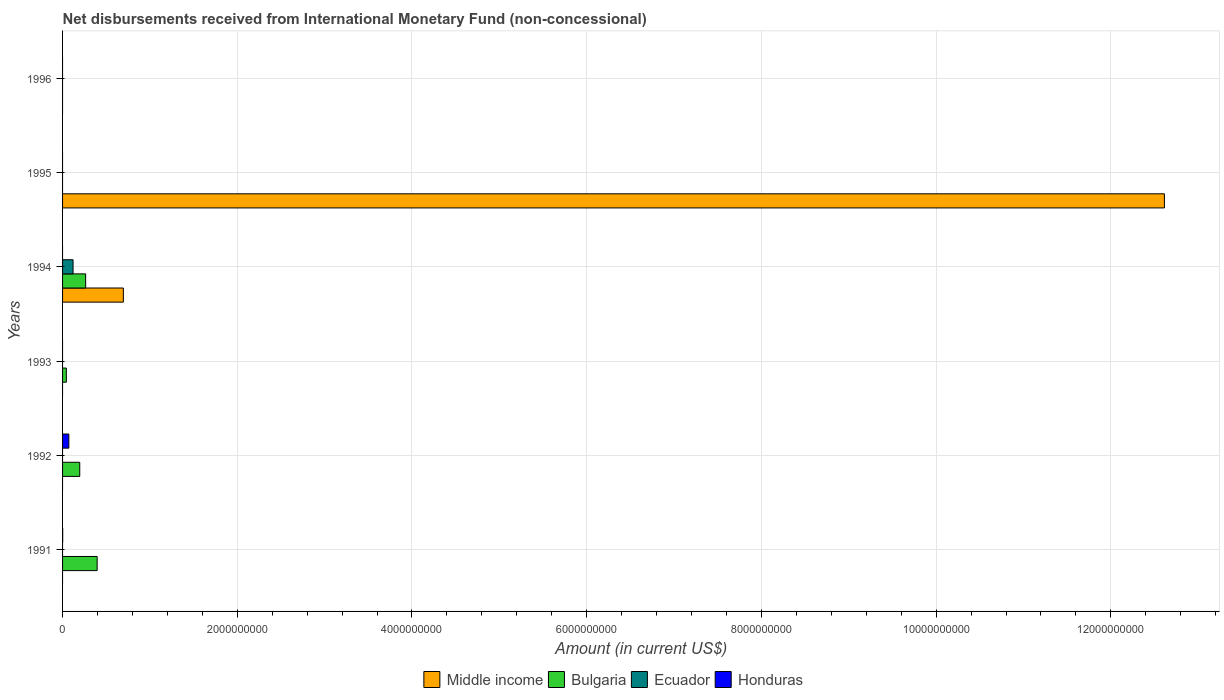How many different coloured bars are there?
Offer a very short reply. 4. Are the number of bars per tick equal to the number of legend labels?
Provide a short and direct response. No. How many bars are there on the 5th tick from the top?
Provide a succinct answer. 2. How many bars are there on the 4th tick from the bottom?
Make the answer very short. 3. What is the amount of disbursements received from International Monetary Fund in Ecuador in 1993?
Your answer should be very brief. 0. Across all years, what is the maximum amount of disbursements received from International Monetary Fund in Middle income?
Offer a very short reply. 1.26e+1. In which year was the amount of disbursements received from International Monetary Fund in Ecuador maximum?
Ensure brevity in your answer.  1994. What is the total amount of disbursements received from International Monetary Fund in Middle income in the graph?
Your answer should be compact. 1.33e+1. What is the difference between the amount of disbursements received from International Monetary Fund in Bulgaria in 1993 and that in 1994?
Offer a terse response. -2.21e+08. What is the difference between the amount of disbursements received from International Monetary Fund in Honduras in 1992 and the amount of disbursements received from International Monetary Fund in Middle income in 1996?
Your response must be concise. 7.19e+07. What is the average amount of disbursements received from International Monetary Fund in Middle income per year?
Make the answer very short. 2.22e+09. In the year 1991, what is the difference between the amount of disbursements received from International Monetary Fund in Honduras and amount of disbursements received from International Monetary Fund in Bulgaria?
Provide a succinct answer. -3.94e+08. What is the ratio of the amount of disbursements received from International Monetary Fund in Bulgaria in 1991 to that in 1993?
Your answer should be very brief. 9.14. What is the difference between the highest and the second highest amount of disbursements received from International Monetary Fund in Bulgaria?
Make the answer very short. 1.32e+08. What is the difference between the highest and the lowest amount of disbursements received from International Monetary Fund in Honduras?
Ensure brevity in your answer.  7.19e+07. Is it the case that in every year, the sum of the amount of disbursements received from International Monetary Fund in Middle income and amount of disbursements received from International Monetary Fund in Ecuador is greater than the sum of amount of disbursements received from International Monetary Fund in Honduras and amount of disbursements received from International Monetary Fund in Bulgaria?
Keep it short and to the point. No. Is it the case that in every year, the sum of the amount of disbursements received from International Monetary Fund in Ecuador and amount of disbursements received from International Monetary Fund in Honduras is greater than the amount of disbursements received from International Monetary Fund in Middle income?
Make the answer very short. No. How many bars are there?
Offer a terse response. 9. How many years are there in the graph?
Make the answer very short. 6. Does the graph contain any zero values?
Provide a succinct answer. Yes. Where does the legend appear in the graph?
Your answer should be compact. Bottom center. How many legend labels are there?
Your answer should be very brief. 4. How are the legend labels stacked?
Your answer should be compact. Horizontal. What is the title of the graph?
Your response must be concise. Net disbursements received from International Monetary Fund (non-concessional). What is the Amount (in current US$) in Bulgaria in 1991?
Your answer should be compact. 3.96e+08. What is the Amount (in current US$) in Honduras in 1991?
Give a very brief answer. 1.35e+06. What is the Amount (in current US$) in Bulgaria in 1992?
Keep it short and to the point. 1.97e+08. What is the Amount (in current US$) in Ecuador in 1992?
Keep it short and to the point. 0. What is the Amount (in current US$) of Honduras in 1992?
Keep it short and to the point. 7.19e+07. What is the Amount (in current US$) in Middle income in 1993?
Offer a terse response. 0. What is the Amount (in current US$) in Bulgaria in 1993?
Give a very brief answer. 4.33e+07. What is the Amount (in current US$) in Honduras in 1993?
Your response must be concise. 0. What is the Amount (in current US$) of Middle income in 1994?
Your answer should be compact. 6.96e+08. What is the Amount (in current US$) in Bulgaria in 1994?
Ensure brevity in your answer.  2.64e+08. What is the Amount (in current US$) in Ecuador in 1994?
Your response must be concise. 1.20e+08. What is the Amount (in current US$) in Honduras in 1994?
Keep it short and to the point. 0. What is the Amount (in current US$) of Middle income in 1995?
Ensure brevity in your answer.  1.26e+1. What is the Amount (in current US$) in Honduras in 1995?
Ensure brevity in your answer.  0. What is the Amount (in current US$) in Bulgaria in 1996?
Your answer should be compact. 0. Across all years, what is the maximum Amount (in current US$) in Middle income?
Your answer should be very brief. 1.26e+1. Across all years, what is the maximum Amount (in current US$) of Bulgaria?
Keep it short and to the point. 3.96e+08. Across all years, what is the maximum Amount (in current US$) of Ecuador?
Make the answer very short. 1.20e+08. Across all years, what is the maximum Amount (in current US$) in Honduras?
Your response must be concise. 7.19e+07. Across all years, what is the minimum Amount (in current US$) in Ecuador?
Provide a succinct answer. 0. What is the total Amount (in current US$) of Middle income in the graph?
Offer a terse response. 1.33e+1. What is the total Amount (in current US$) in Bulgaria in the graph?
Provide a short and direct response. 9.00e+08. What is the total Amount (in current US$) in Ecuador in the graph?
Your answer should be very brief. 1.20e+08. What is the total Amount (in current US$) in Honduras in the graph?
Give a very brief answer. 7.32e+07. What is the difference between the Amount (in current US$) of Bulgaria in 1991 and that in 1992?
Your response must be concise. 1.99e+08. What is the difference between the Amount (in current US$) of Honduras in 1991 and that in 1992?
Provide a succinct answer. -7.05e+07. What is the difference between the Amount (in current US$) of Bulgaria in 1991 and that in 1993?
Your answer should be compact. 3.53e+08. What is the difference between the Amount (in current US$) in Bulgaria in 1991 and that in 1994?
Provide a short and direct response. 1.32e+08. What is the difference between the Amount (in current US$) in Bulgaria in 1992 and that in 1993?
Offer a terse response. 1.53e+08. What is the difference between the Amount (in current US$) of Bulgaria in 1992 and that in 1994?
Your response must be concise. -6.75e+07. What is the difference between the Amount (in current US$) in Bulgaria in 1993 and that in 1994?
Your answer should be very brief. -2.21e+08. What is the difference between the Amount (in current US$) in Middle income in 1994 and that in 1995?
Your answer should be very brief. -1.19e+1. What is the difference between the Amount (in current US$) of Bulgaria in 1991 and the Amount (in current US$) of Honduras in 1992?
Provide a succinct answer. 3.24e+08. What is the difference between the Amount (in current US$) of Bulgaria in 1991 and the Amount (in current US$) of Ecuador in 1994?
Keep it short and to the point. 2.76e+08. What is the difference between the Amount (in current US$) in Bulgaria in 1992 and the Amount (in current US$) in Ecuador in 1994?
Your answer should be compact. 7.65e+07. What is the difference between the Amount (in current US$) of Bulgaria in 1993 and the Amount (in current US$) of Ecuador in 1994?
Your answer should be very brief. -7.69e+07. What is the average Amount (in current US$) of Middle income per year?
Offer a terse response. 2.22e+09. What is the average Amount (in current US$) in Bulgaria per year?
Provide a succinct answer. 1.50e+08. What is the average Amount (in current US$) of Ecuador per year?
Give a very brief answer. 2.00e+07. What is the average Amount (in current US$) in Honduras per year?
Provide a succinct answer. 1.22e+07. In the year 1991, what is the difference between the Amount (in current US$) in Bulgaria and Amount (in current US$) in Honduras?
Keep it short and to the point. 3.94e+08. In the year 1992, what is the difference between the Amount (in current US$) of Bulgaria and Amount (in current US$) of Honduras?
Give a very brief answer. 1.25e+08. In the year 1994, what is the difference between the Amount (in current US$) of Middle income and Amount (in current US$) of Bulgaria?
Give a very brief answer. 4.32e+08. In the year 1994, what is the difference between the Amount (in current US$) in Middle income and Amount (in current US$) in Ecuador?
Give a very brief answer. 5.76e+08. In the year 1994, what is the difference between the Amount (in current US$) in Bulgaria and Amount (in current US$) in Ecuador?
Keep it short and to the point. 1.44e+08. What is the ratio of the Amount (in current US$) of Bulgaria in 1991 to that in 1992?
Offer a very short reply. 2.01. What is the ratio of the Amount (in current US$) of Honduras in 1991 to that in 1992?
Keep it short and to the point. 0.02. What is the ratio of the Amount (in current US$) of Bulgaria in 1991 to that in 1993?
Offer a very short reply. 9.14. What is the ratio of the Amount (in current US$) in Bulgaria in 1991 to that in 1994?
Ensure brevity in your answer.  1.5. What is the ratio of the Amount (in current US$) of Bulgaria in 1992 to that in 1993?
Your response must be concise. 4.55. What is the ratio of the Amount (in current US$) in Bulgaria in 1992 to that in 1994?
Keep it short and to the point. 0.74. What is the ratio of the Amount (in current US$) of Bulgaria in 1993 to that in 1994?
Offer a terse response. 0.16. What is the ratio of the Amount (in current US$) in Middle income in 1994 to that in 1995?
Your answer should be very brief. 0.06. What is the difference between the highest and the second highest Amount (in current US$) of Bulgaria?
Your answer should be very brief. 1.32e+08. What is the difference between the highest and the lowest Amount (in current US$) in Middle income?
Offer a terse response. 1.26e+1. What is the difference between the highest and the lowest Amount (in current US$) of Bulgaria?
Your answer should be compact. 3.96e+08. What is the difference between the highest and the lowest Amount (in current US$) of Ecuador?
Your answer should be compact. 1.20e+08. What is the difference between the highest and the lowest Amount (in current US$) of Honduras?
Offer a very short reply. 7.19e+07. 